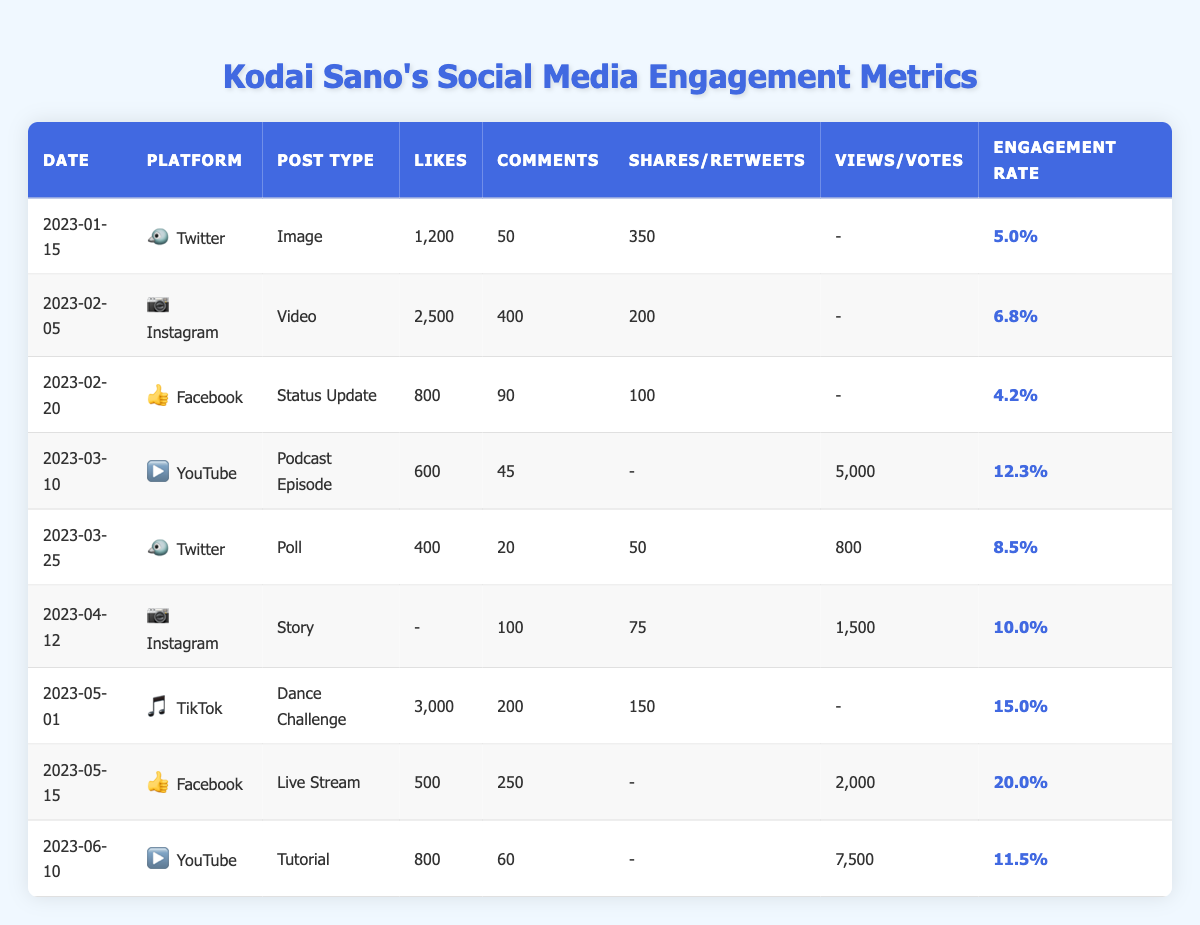What was the post with the highest engagement rate? The post with the highest engagement rate is the one from 2023-05-15 on Facebook with an engagement rate of 20.0%.
Answer: 20.0% Which platform had the most likes on a single post? The Instagram post on 2023-05-01 had the most likes, totaling 3,000.
Answer: 3,000 How many total comments did Kodai Sano receive from all posts? Adding the comments from all posts: 50 (Twitter) + 400 (Instagram) + 90 (Facebook) + 45 (YouTube) + 20 (Twitter) + 100 (Instagram) + 200 (TikTok) + 250 (Facebook) + 60 (YouTube) = 1,415.
Answer: 1,415 What type of post had the highest number of views? The YouTube tutorial on 2023-06-10 had the highest number of views at 7,500.
Answer: 7,500 What is the average engagement rate across all posts? To find the average, sum the engagement rates: (5.0 + 6.8 + 4.2 + 12.3 + 8.5 + 10.0 + 15.0 + 20.0 + 11.5) = 89.3, and divide by the number of posts (9), giving an average of 89.3 / 9 = 9.9.
Answer: 9.9 Which post had the least interaction in terms of likes, comments, and shares/retweets combined? The Twitter post from 2023-02-20 had 800 likes, 90 comments, and 100 shares, totaling 990 interactions. This is less than the other posts.
Answer: 990 Is there a post type that consistently had higher engagement rates? The dance challenge on TikTok and the live stream on Facebook both had high engagement rates (15.0% and 20.0%, respectively), indicating video content performed better overall.
Answer: Yes What was the total number of votes collected in the polls? The total number of votes is 800 from the Twitter poll on 2023-03-25.
Answer: 800 Can we conclude that videos generally received more engagement than other types of posts? By reviewing the engagement rates, the video posts (YouTube and TikTok) had high engagement rates compared to image or text-based posts. Hence, yes, videos seem to garner more engagement.
Answer: Yes Which platform had the least engagement overall? Facebook had a post on 2023-02-20 with an engagement rate of 4.2%, which is the lowest in the table.
Answer: Facebook 